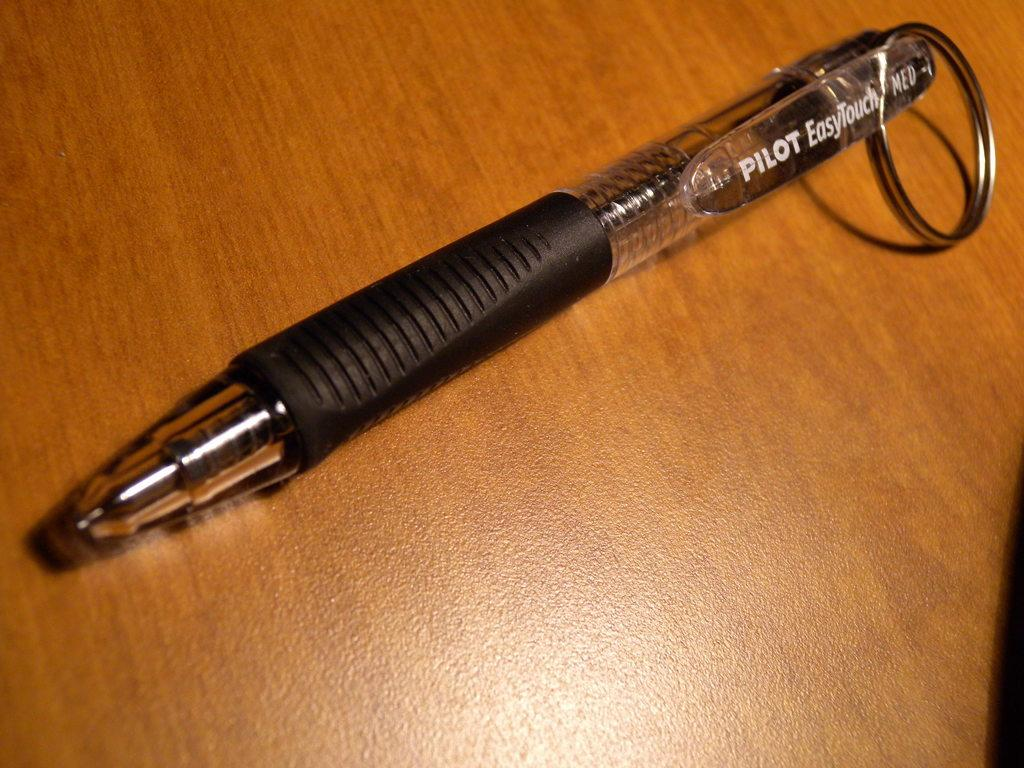What object can be seen in the image? There is a pen in the image. What is the pen resting on? The pen is on a wooden surface. What type of pie is being served on the tray in the image? There is no tray or pie present in the image; it only features a pen on a wooden surface. 